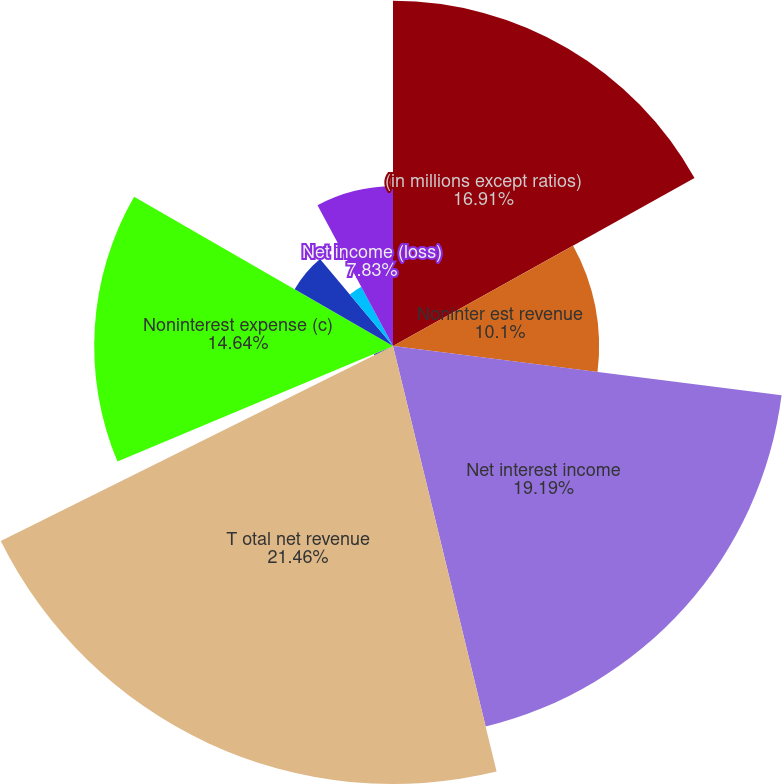Convert chart. <chart><loc_0><loc_0><loc_500><loc_500><pie_chart><fcel>(in millions except ratios)<fcel>Noninter est revenue<fcel>Net interest income<fcel>T otal net revenue<fcel>Provision for credit losses<fcel>Noninterest expense (c)<fcel>Income (loss) from continuing<fcel>Income tax expense (benefit)<fcel>Net income (loss)<nl><fcel>16.91%<fcel>10.1%<fcel>19.19%<fcel>21.46%<fcel>1.02%<fcel>14.64%<fcel>5.56%<fcel>3.29%<fcel>7.83%<nl></chart> 